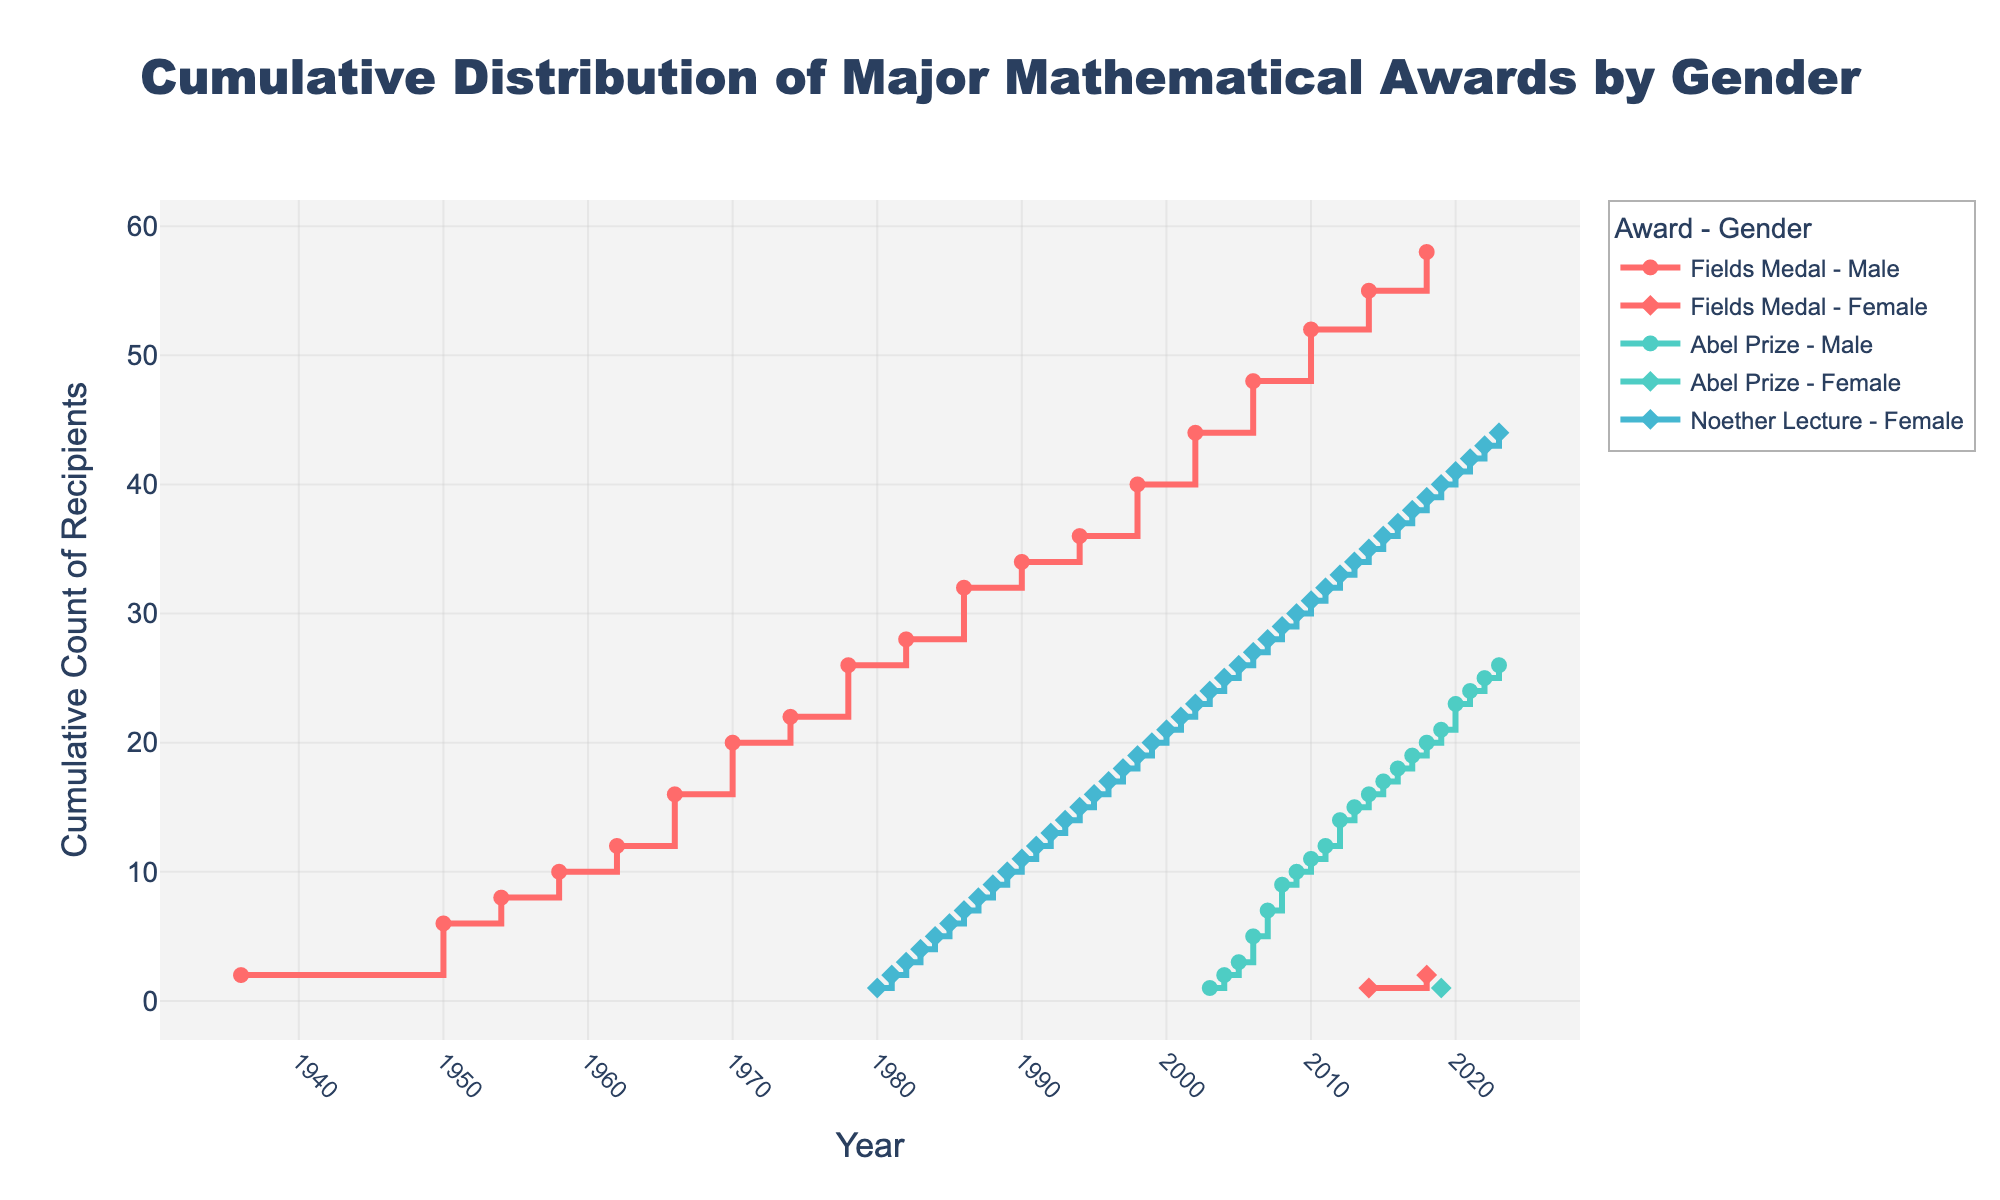What is the title of the plot? The title is located at the top of the figure and is centered with a font size of 24. It reads "Cumulative Distribution of Major Mathematical Awards by Gender".
Answer: "Cumulative Distribution of Major Mathematical Awards by Gender" How does the x-axis of the plot span? The x-axis represents the years, starting from 1936 and ending at 2023, with timestamps at regular intervals.
Answer: From 1936 to 2023 What pattern can be observed in the cumulative count of male Fields Medal recipients? The cumulative count increases at various years starting from 1936, with rises in counts typically every four years. Overall, the line shows a steady upward trend over time.
Answer: A steady upward trend with increases roughly every four years When did the first female receive the Fields Medal according to the plot? By examining the line for female Fields Medal recipients, one can see that it starts rising in 2014. This indicates that the first female recipient got the Fields Medal in 2014.
Answer: 2014 Compare the cumulative counts of female Noether Lecture recipients to the cumulative counts of female Fields Medal recipients by 2023. By observing the final year, 2023, one can see that female Noether Lecture recipients have a cumulative count of 44, whereas female Fields Medal recipients have a cumulative count of 2.
Answer: Female Noether Lecture: 44, Female Fields Medal: 2 In which year did the cumulative count of male Fields Medal recipients reach 10? By following the line representing the cumulative count of male Fields Medal recipients, which increases every few years, we can see that it reaches 10 in the year 1970.
Answer: 1970 What is the difference in the cumulative count between male and female Abel Prize recipients in 2023? The cumulative count for male Abel Prize recipients is 27 and for female Abel Prize recipients is 1 until 2023. The difference is calculated by subtracting 1 from 27.
Answer: 26 Which gender started receiving more linearly increasing counts for the Noether Lecture awards since 1980? Observing the plot for Noether Lecture awards, male recipients are non-existent while the female recipients show a consistent linear increase starting in 1980.
Answer: Female Which award has the highest cumulative count for female recipients by 2023, and what insights can you gather from this? Examining the plot, female recipients of the Noether Lecture have the highest cumulative count of 44 by 2023. This suggests that the Noether Lecture has been particularly significant in recognizing female mathematicians.
Answer: Noether Lecture with a count of 44 How does the cumulative distribution of Abel Prize for male and female recipients compare after 2019? By inspecting the lines representing male and female Abel Prize recipients, we see that the cumulative count for males continues to increase steadily reaching higher values while females show a slight increase only in 2019.
Answer: Males continue to increase steadily, females show a slight increase only in 2019 